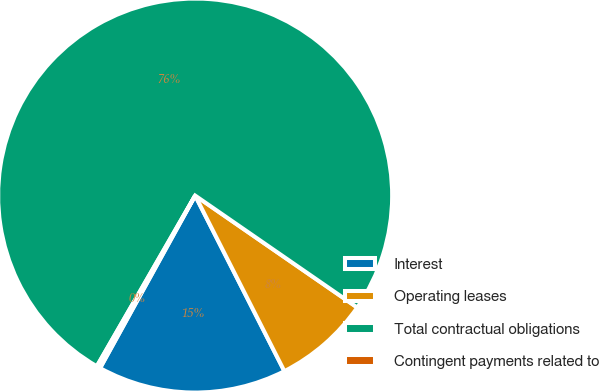Convert chart to OTSL. <chart><loc_0><loc_0><loc_500><loc_500><pie_chart><fcel>Interest<fcel>Operating leases<fcel>Total contractual obligations<fcel>Contingent payments related to<nl><fcel>15.5%<fcel>7.9%<fcel>76.31%<fcel>0.3%<nl></chart> 